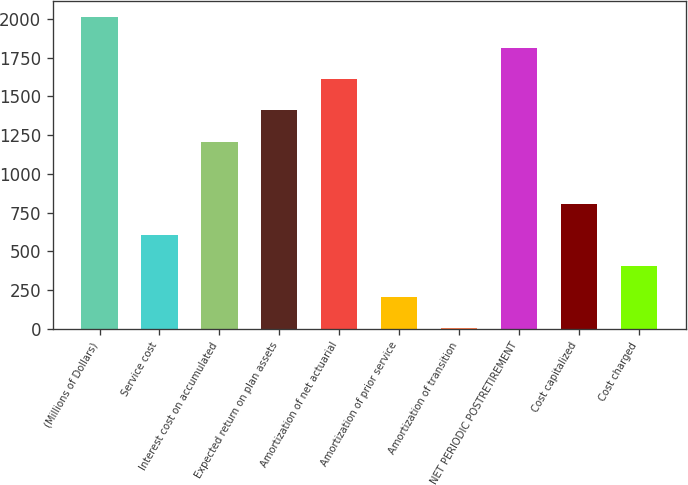Convert chart. <chart><loc_0><loc_0><loc_500><loc_500><bar_chart><fcel>(Millions of Dollars)<fcel>Service cost<fcel>Interest cost on accumulated<fcel>Expected return on plan assets<fcel>Amortization of net actuarial<fcel>Amortization of prior service<fcel>Amortization of transition<fcel>NET PERIODIC POSTRETIREMENT<fcel>Cost capitalized<fcel>Cost charged<nl><fcel>2011<fcel>606.1<fcel>1208.2<fcel>1408.9<fcel>1609.6<fcel>204.7<fcel>4<fcel>1810.3<fcel>806.8<fcel>405.4<nl></chart> 